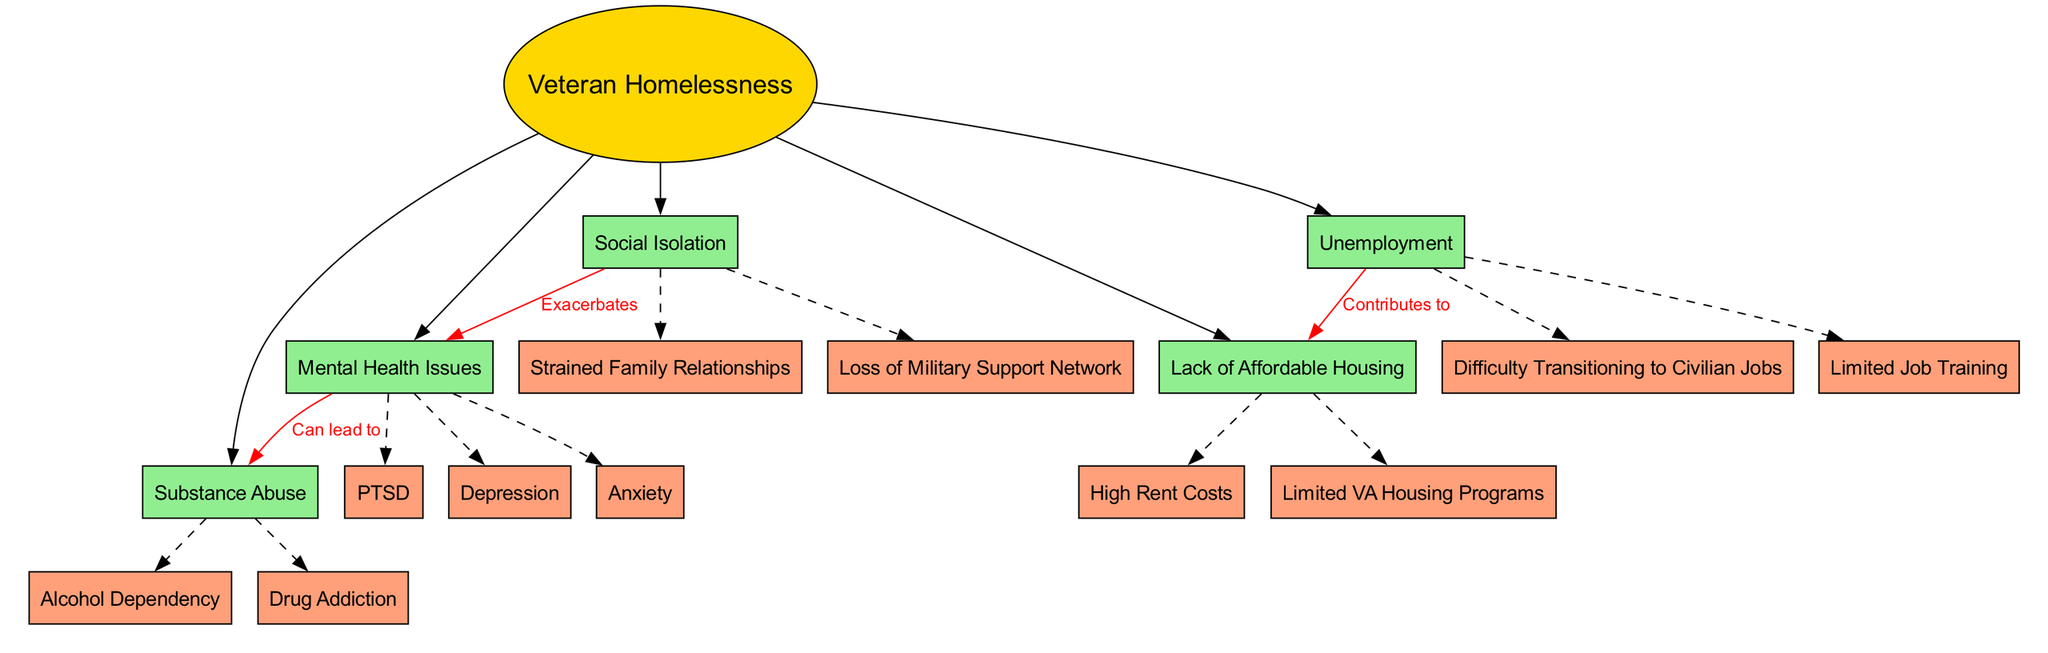What is the central concept of the diagram? The diagram presents "Veteran Homelessness" as the central concept, labeled as the main theme at the center of the visual structure.
Answer: Veteran Homelessness How many main factors contribute to veteran homelessness? The diagram lists five main factors connected to veteran homelessness, each represented as a separate node branching out from the central concept.
Answer: Five Which subfactor is related to "Mental Health Issues"? "PTSD" is one of the subfactors listed under "Mental Health Issues," indicating a specific issue that veterans may face.
Answer: PTSD What relationship is indicated between "Mental Health Issues" and "Substance Abuse"? The diagram shows a directed edge labeled "Can lead to" from "Mental Health Issues" to "Substance Abuse," indicating that mental health challenges may contribute to substance abuse behavior.
Answer: Can lead to What contributes to the "Lack of Affordable Housing"? The diagram indicates that "Unemployment" contributes to the "Lack of Affordable Housing," showing a directed connection that emphasizes the role of joblessness in housing issues.
Answer: Unemployment Which subfactor is associated with "Social Isolation"? "Strained Family Relationships" is a subfactor associated with "Social Isolation," providing insight into how social connections can affect veterans' living conditions.
Answer: Strained Family Relationships How does social isolation impact mental health according to the diagram? The diagram illustrates a connection labeled "Exacerbates" from "Social Isolation" to "Mental Health Issues," suggesting that isolation can worsen mental health conditions among veterans.
Answer: Exacerbates What is the color used for the subfactors in the diagram? The subfactors are colored "lightsalmon," which visually differentiates them from the main factors and helps categorize the types of issues faced by veterans.
Answer: Lightsalmon Which main factor has the subfactor "Drug Addiction"? The main factor is "Substance Abuse," from which "Drug Addiction" extends as a related issue, represented by a dashed line in the diagram.
Answer: Substance Abuse 